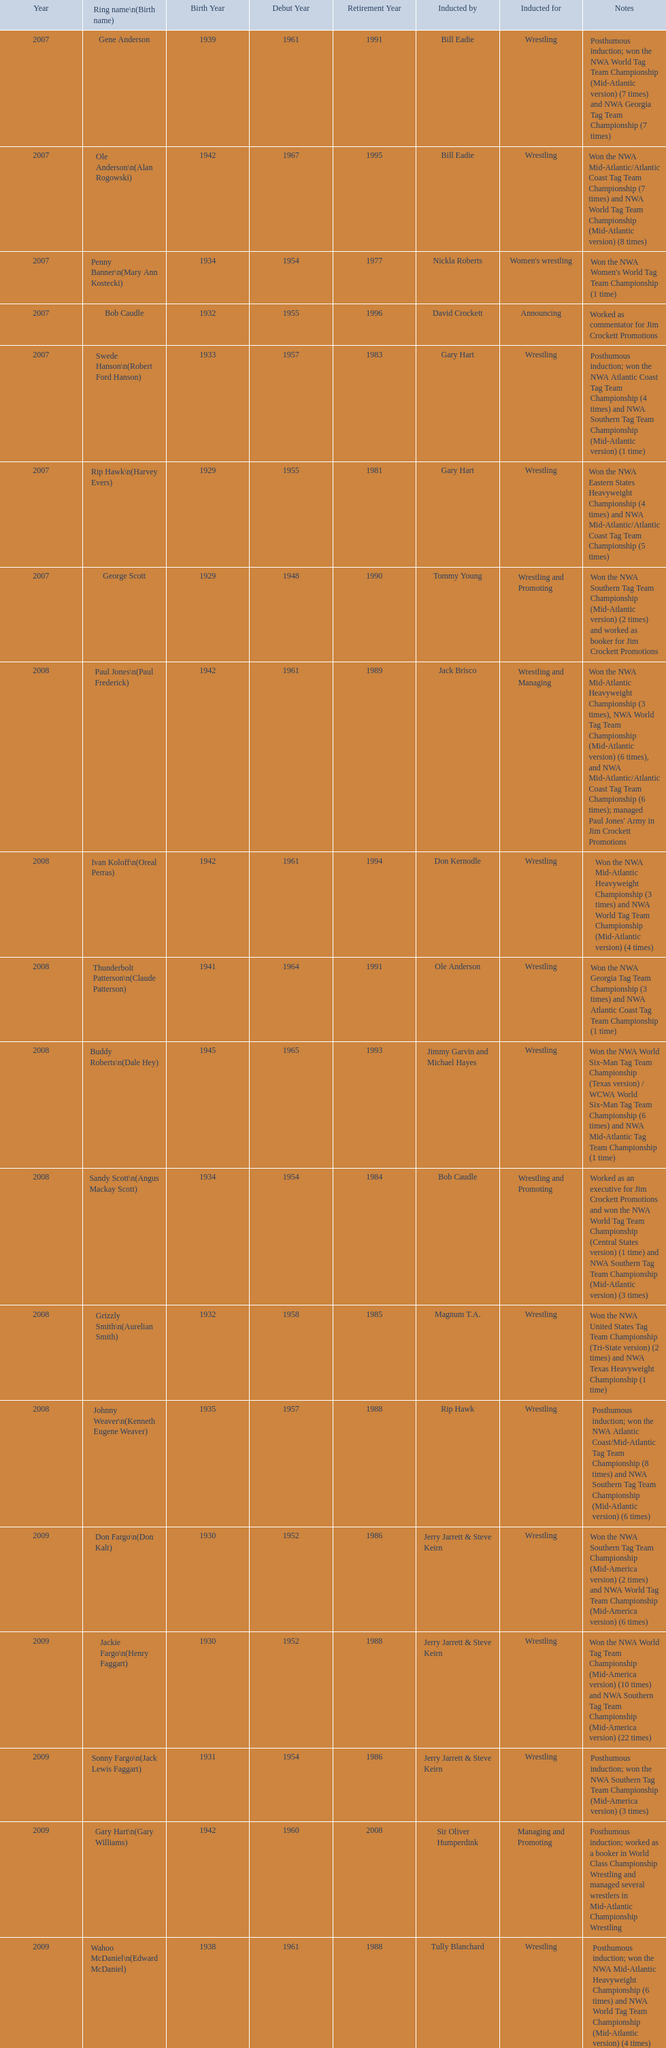Who was the announcer inducted into the hall of heroes in 2007? Bob Caudle. Who was the next announcer to be inducted? Lance Russell. 